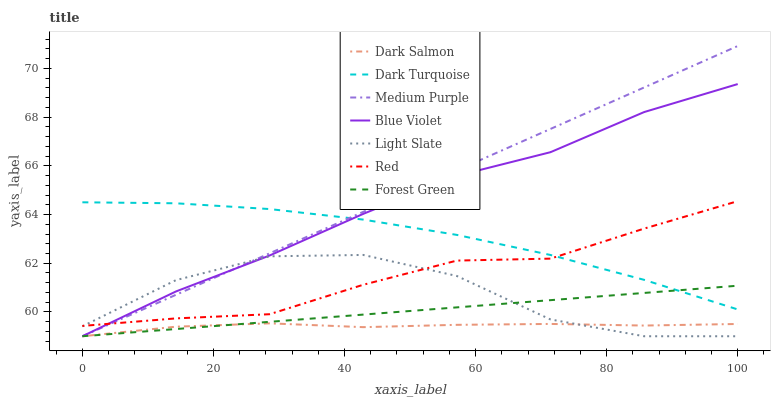Does Dark Salmon have the minimum area under the curve?
Answer yes or no. Yes. Does Medium Purple have the maximum area under the curve?
Answer yes or no. Yes. Does Dark Turquoise have the minimum area under the curve?
Answer yes or no. No. Does Dark Turquoise have the maximum area under the curve?
Answer yes or no. No. Is Forest Green the smoothest?
Answer yes or no. Yes. Is Light Slate the roughest?
Answer yes or no. Yes. Is Dark Turquoise the smoothest?
Answer yes or no. No. Is Dark Turquoise the roughest?
Answer yes or no. No. Does Dark Turquoise have the lowest value?
Answer yes or no. No. Does Medium Purple have the highest value?
Answer yes or no. Yes. Does Dark Turquoise have the highest value?
Answer yes or no. No. Is Dark Salmon less than Red?
Answer yes or no. Yes. Is Red greater than Forest Green?
Answer yes or no. Yes. Does Red intersect Blue Violet?
Answer yes or no. Yes. Is Red less than Blue Violet?
Answer yes or no. No. Is Red greater than Blue Violet?
Answer yes or no. No. Does Dark Salmon intersect Red?
Answer yes or no. No. 